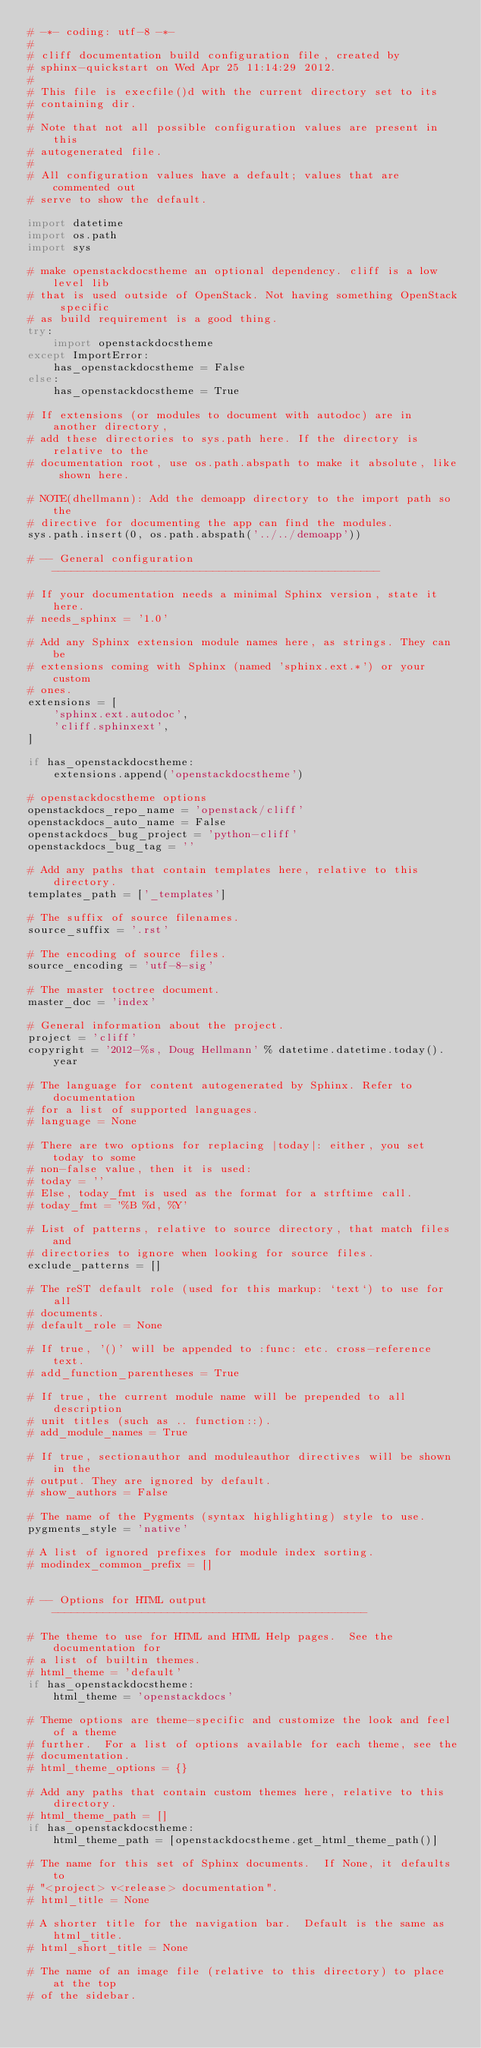Convert code to text. <code><loc_0><loc_0><loc_500><loc_500><_Python_># -*- coding: utf-8 -*-
#
# cliff documentation build configuration file, created by
# sphinx-quickstart on Wed Apr 25 11:14:29 2012.
#
# This file is execfile()d with the current directory set to its
# containing dir.
#
# Note that not all possible configuration values are present in this
# autogenerated file.
#
# All configuration values have a default; values that are commented out
# serve to show the default.

import datetime
import os.path
import sys

# make openstackdocstheme an optional dependency. cliff is a low level lib
# that is used outside of OpenStack. Not having something OpenStack specific
# as build requirement is a good thing.
try:
    import openstackdocstheme
except ImportError:
    has_openstackdocstheme = False
else:
    has_openstackdocstheme = True

# If extensions (or modules to document with autodoc) are in another directory,
# add these directories to sys.path here. If the directory is relative to the
# documentation root, use os.path.abspath to make it absolute, like shown here.

# NOTE(dhellmann): Add the demoapp directory to the import path so the
# directive for documenting the app can find the modules.
sys.path.insert(0, os.path.abspath('../../demoapp'))

# -- General configuration ---------------------------------------------------

# If your documentation needs a minimal Sphinx version, state it here.
# needs_sphinx = '1.0'

# Add any Sphinx extension module names here, as strings. They can be
# extensions coming with Sphinx (named 'sphinx.ext.*') or your custom
# ones.
extensions = [
    'sphinx.ext.autodoc',
    'cliff.sphinxext',
]

if has_openstackdocstheme:
    extensions.append('openstackdocstheme')

# openstackdocstheme options
openstackdocs_repo_name = 'openstack/cliff'
openstackdocs_auto_name = False
openstackdocs_bug_project = 'python-cliff'
openstackdocs_bug_tag = ''

# Add any paths that contain templates here, relative to this directory.
templates_path = ['_templates']

# The suffix of source filenames.
source_suffix = '.rst'

# The encoding of source files.
source_encoding = 'utf-8-sig'

# The master toctree document.
master_doc = 'index'

# General information about the project.
project = 'cliff'
copyright = '2012-%s, Doug Hellmann' % datetime.datetime.today().year

# The language for content autogenerated by Sphinx. Refer to documentation
# for a list of supported languages.
# language = None

# There are two options for replacing |today|: either, you set today to some
# non-false value, then it is used:
# today = ''
# Else, today_fmt is used as the format for a strftime call.
# today_fmt = '%B %d, %Y'

# List of patterns, relative to source directory, that match files and
# directories to ignore when looking for source files.
exclude_patterns = []

# The reST default role (used for this markup: `text`) to use for all
# documents.
# default_role = None

# If true, '()' will be appended to :func: etc. cross-reference text.
# add_function_parentheses = True

# If true, the current module name will be prepended to all description
# unit titles (such as .. function::).
# add_module_names = True

# If true, sectionauthor and moduleauthor directives will be shown in the
# output. They are ignored by default.
# show_authors = False

# The name of the Pygments (syntax highlighting) style to use.
pygments_style = 'native'

# A list of ignored prefixes for module index sorting.
# modindex_common_prefix = []


# -- Options for HTML output -------------------------------------------------

# The theme to use for HTML and HTML Help pages.  See the documentation for
# a list of builtin themes.
# html_theme = 'default'
if has_openstackdocstheme:
    html_theme = 'openstackdocs'

# Theme options are theme-specific and customize the look and feel of a theme
# further.  For a list of options available for each theme, see the
# documentation.
# html_theme_options = {}

# Add any paths that contain custom themes here, relative to this directory.
# html_theme_path = []
if has_openstackdocstheme:
    html_theme_path = [openstackdocstheme.get_html_theme_path()]

# The name for this set of Sphinx documents.  If None, it defaults to
# "<project> v<release> documentation".
# html_title = None

# A shorter title for the navigation bar.  Default is the same as html_title.
# html_short_title = None

# The name of an image file (relative to this directory) to place at the top
# of the sidebar.</code> 